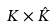Convert formula to latex. <formula><loc_0><loc_0><loc_500><loc_500>K \times { \hat { K } }</formula> 